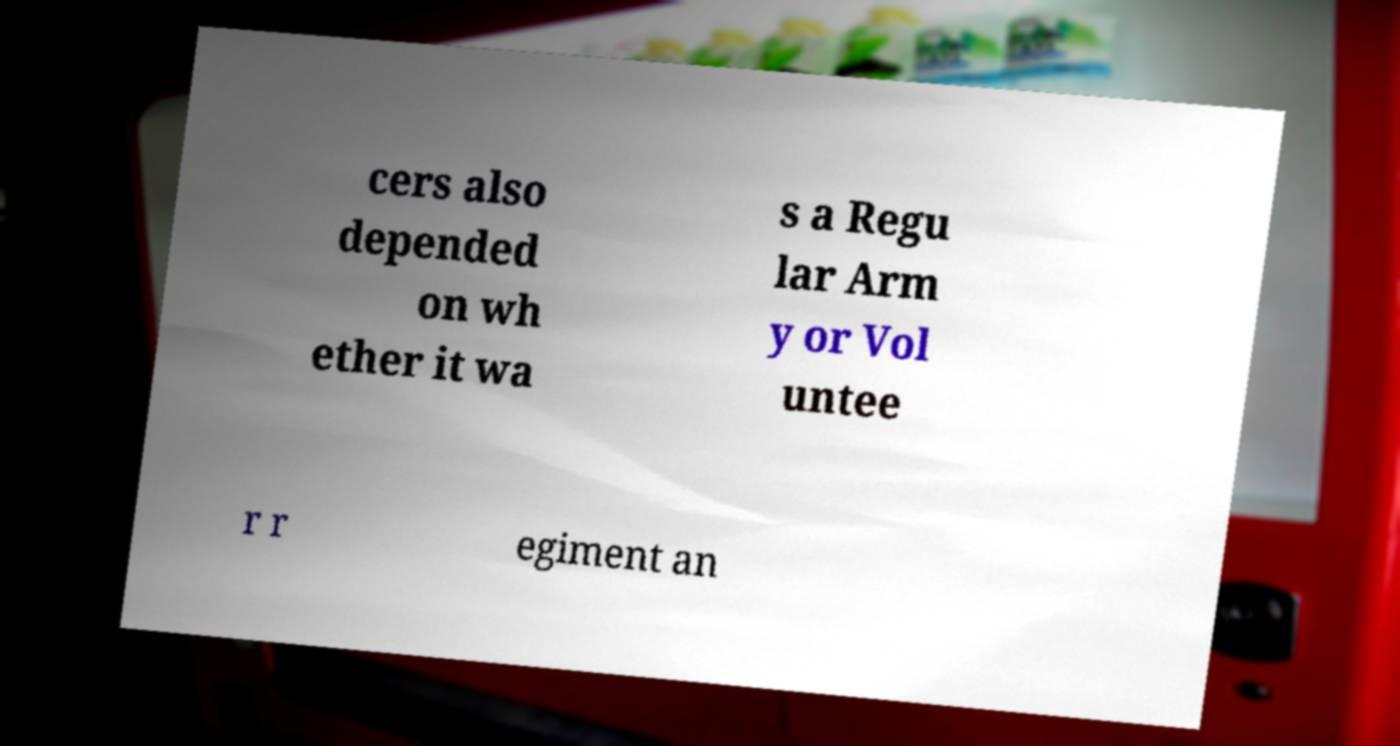Can you read and provide the text displayed in the image?This photo seems to have some interesting text. Can you extract and type it out for me? cers also depended on wh ether it wa s a Regu lar Arm y or Vol untee r r egiment an 